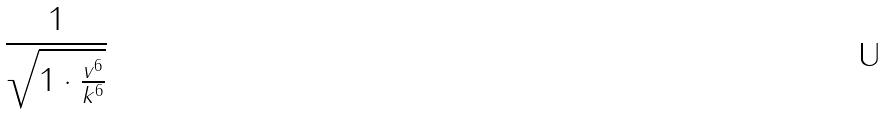<formula> <loc_0><loc_0><loc_500><loc_500>\frac { 1 } { \sqrt { 1 \cdot \frac { v ^ { 6 } } { k ^ { 6 } } } }</formula> 